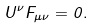Convert formula to latex. <formula><loc_0><loc_0><loc_500><loc_500>U ^ { \nu } F _ { \mu \nu } = 0 .</formula> 